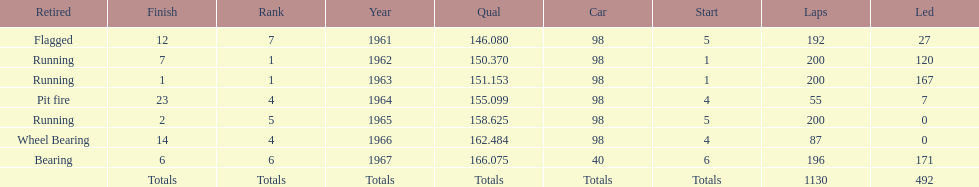Number of times to finish the races running. 3. Parse the full table. {'header': ['Retired', 'Finish', 'Rank', 'Year', 'Qual', 'Car', 'Start', 'Laps', 'Led'], 'rows': [['Flagged', '12', '7', '1961', '146.080', '98', '5', '192', '27'], ['Running', '7', '1', '1962', '150.370', '98', '1', '200', '120'], ['Running', '1', '1', '1963', '151.153', '98', '1', '200', '167'], ['Pit fire', '23', '4', '1964', '155.099', '98', '4', '55', '7'], ['Running', '2', '5', '1965', '158.625', '98', '5', '200', '0'], ['Wheel Bearing', '14', '4', '1966', '162.484', '98', '4', '87', '0'], ['Bearing', '6', '6', '1967', '166.075', '40', '6', '196', '171'], ['', 'Totals', 'Totals', 'Totals', 'Totals', 'Totals', 'Totals', '1130', '492']]} 